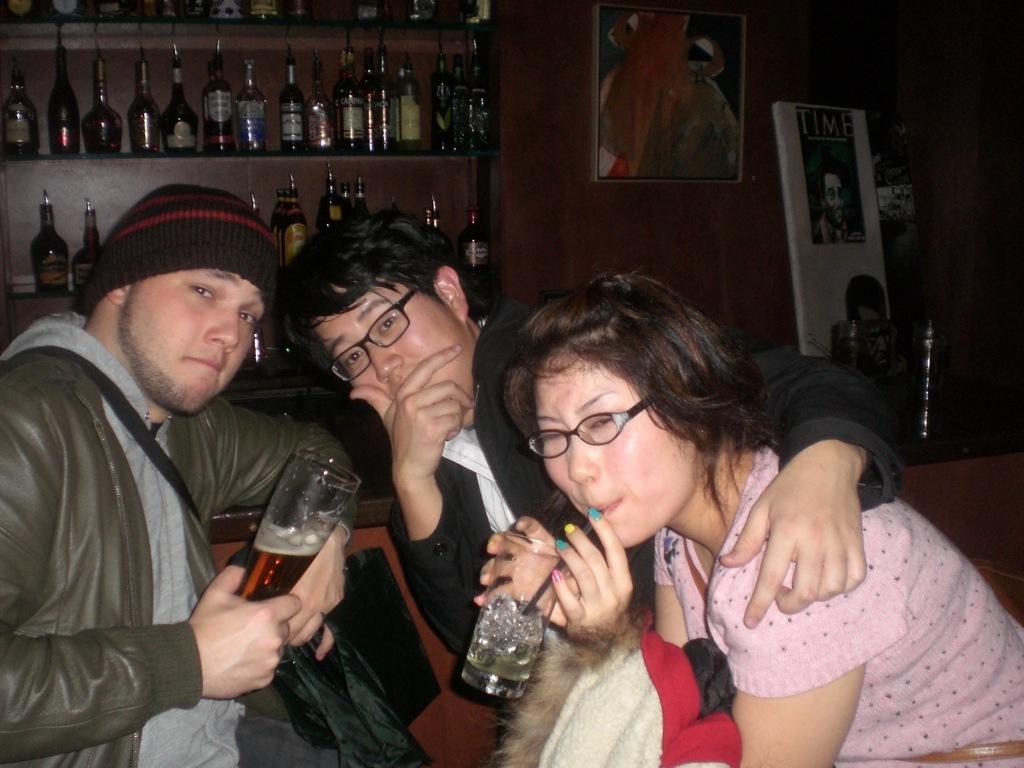How would you summarize this image in a sentence or two? As we can see in the image in the front there are three people sitting. These two are holding glasses. In the background there is a wall, photo frame, banner and shelves filled with bottles. 